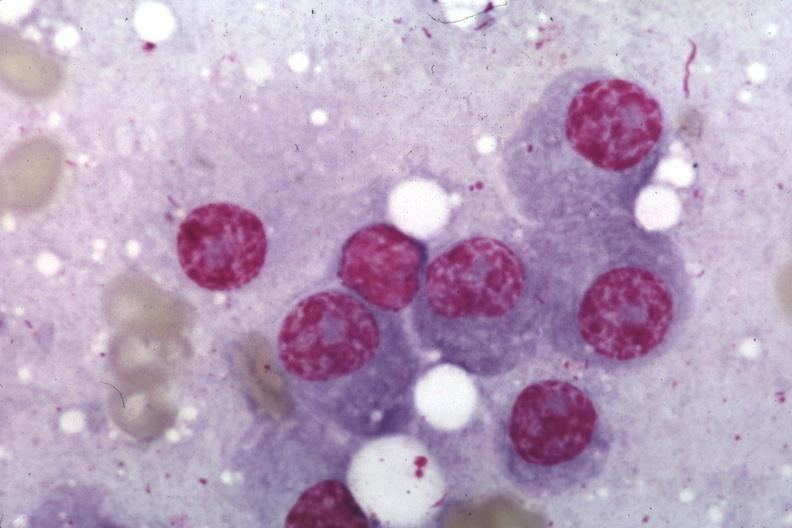what is present?
Answer the question using a single word or phrase. Bone marrow 